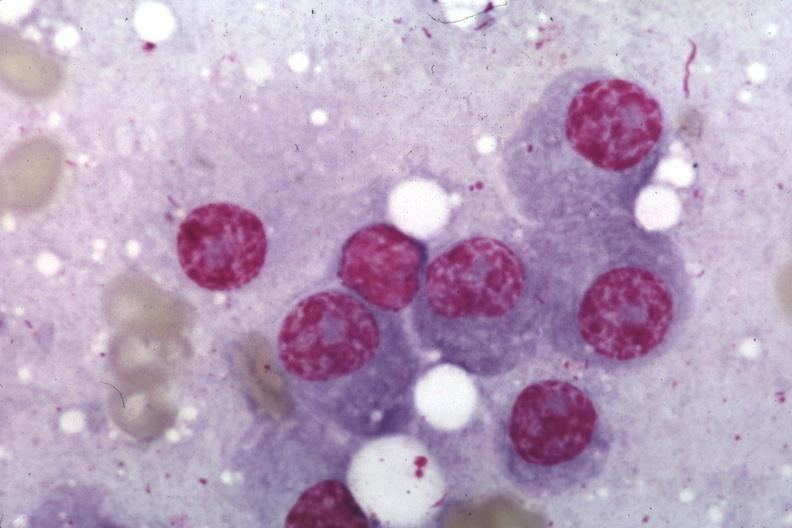what is present?
Answer the question using a single word or phrase. Bone marrow 